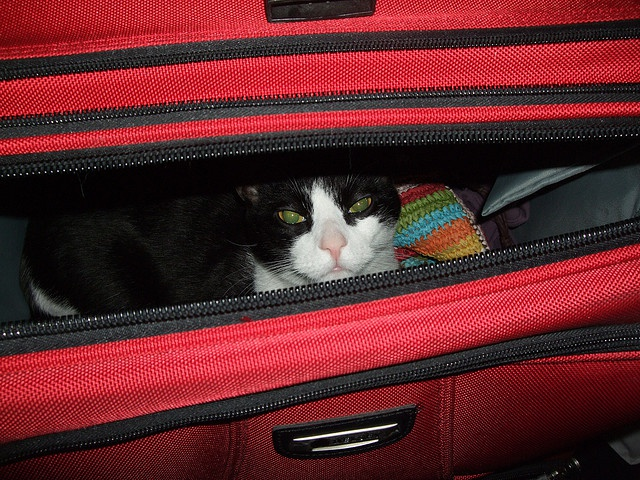Describe the objects in this image and their specific colors. I can see suitcase in maroon, black, brown, and salmon tones and cat in maroon, black, darkgray, lightgray, and gray tones in this image. 